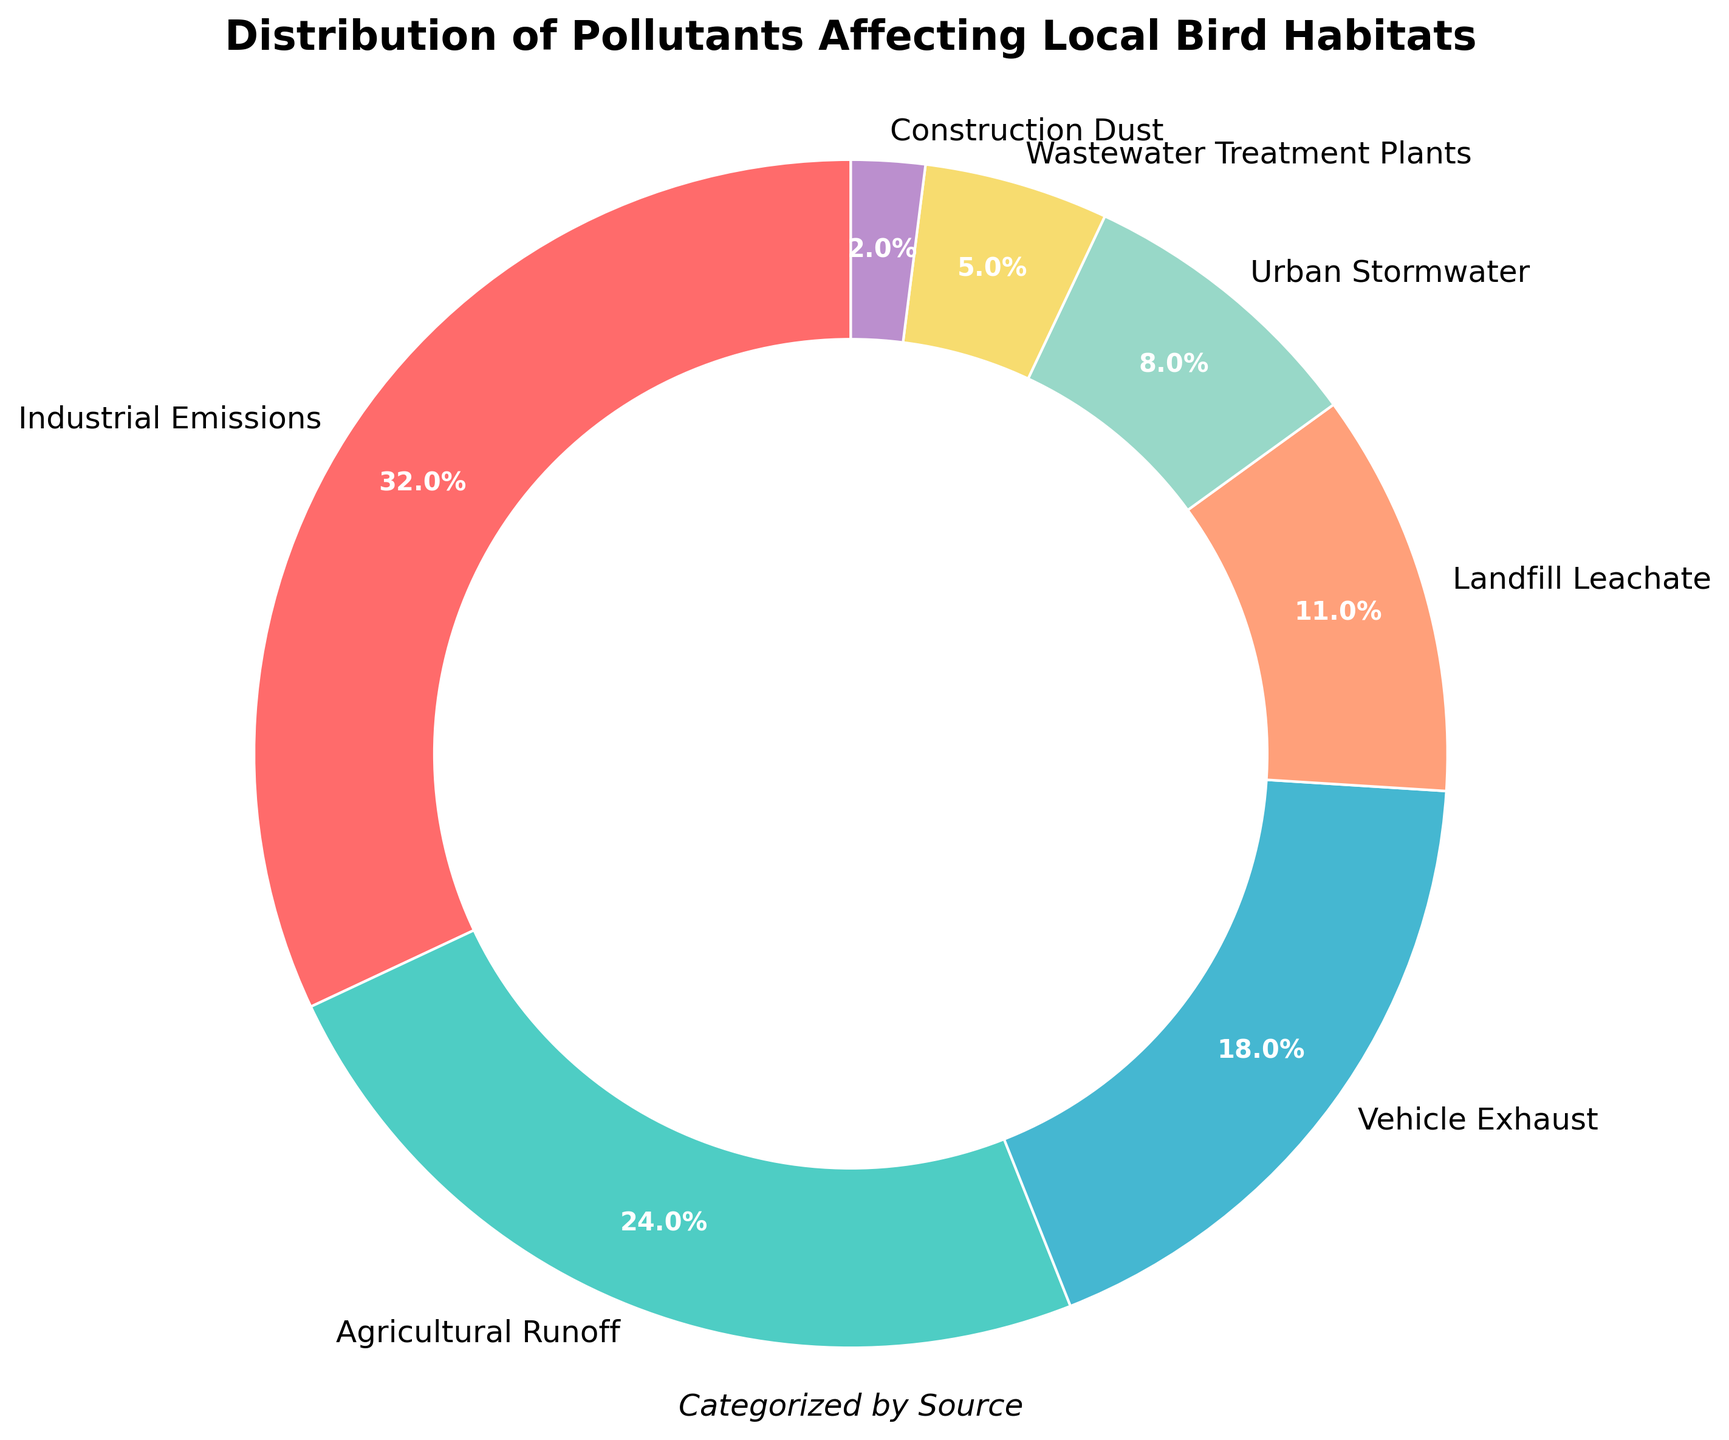What's the percentage of pollutants coming from Urban Stormwater and Wastewater Treatment Plants combined? To find the combined percentage, add the percentages of Urban Stormwater (8%) and Wastewater Treatment Plants (5%). Thus, 8% + 5% = 13%.
Answer: 13% Which pollutant source contributes the largest percentage? The largest percentage in the pie chart is from Industrial Emissions, which is 32%.
Answer: Industrial Emissions What is the visual effect of Industrial Emissions in the pie chart? The Industrial Emissions section is colored in bright red and occupies the largest segment of the chart with a percentage of 32%.
Answer: It is the largest and red How much larger is the percentage of Industrial Emissions compared to Landfill Leachate? Industrial Emissions are 32%, and Landfill Leachate is 11%. To find how much larger Industrial Emissions are, subtract Landfill Leachate's percentage from Industrial Emissions: 32% - 11% = 21%.
Answer: 21% List the pollutant sources that are categorized as having single-digit percentage contributions. The pollutant sources with single-digit percentage contributions are Urban Stormwater (8%), Wastewater Treatment Plants (5%), and Construction Dust (2%).
Answer: Urban Stormwater, Wastewater Treatment Plants, Construction Dust Is the percentage contribution of Agricultural Runoff greater than Vehicle Exhaust? Agricultural Runoff contributes 24%, while Vehicle Exhaust contributes 18%. 24% is greater than 18%.
Answer: Yes Which color represents the Agricultural Runoff section in the chart? The Agricultural Runoff section is colored in teal-green and represents 24% of the pie chart.
Answer: Teal-green By how much does the percentage of Vehicle Exhaust exceed that of Urban Stormwater? Vehicle Exhaust contributes 18%, while Urban Stormwater contributes 8%. Subtract the smaller percentage from the larger one: 18% - 8% = 10%.
Answer: 10% What is the total percentage contribution of the three smallest pollutant sources? The three smallest pollutant sources are Wastewater Treatment Plants (5%), Urban Stormwater (8%), and Construction Dust (2%). Add their percentages together: 5% + 8% + 2% = 15%.
Answer: 15% Which pollutant source has the smallest contribution? The smallest contributing pollutant source is Construction Dust with 2%.
Answer: Construction Dust 